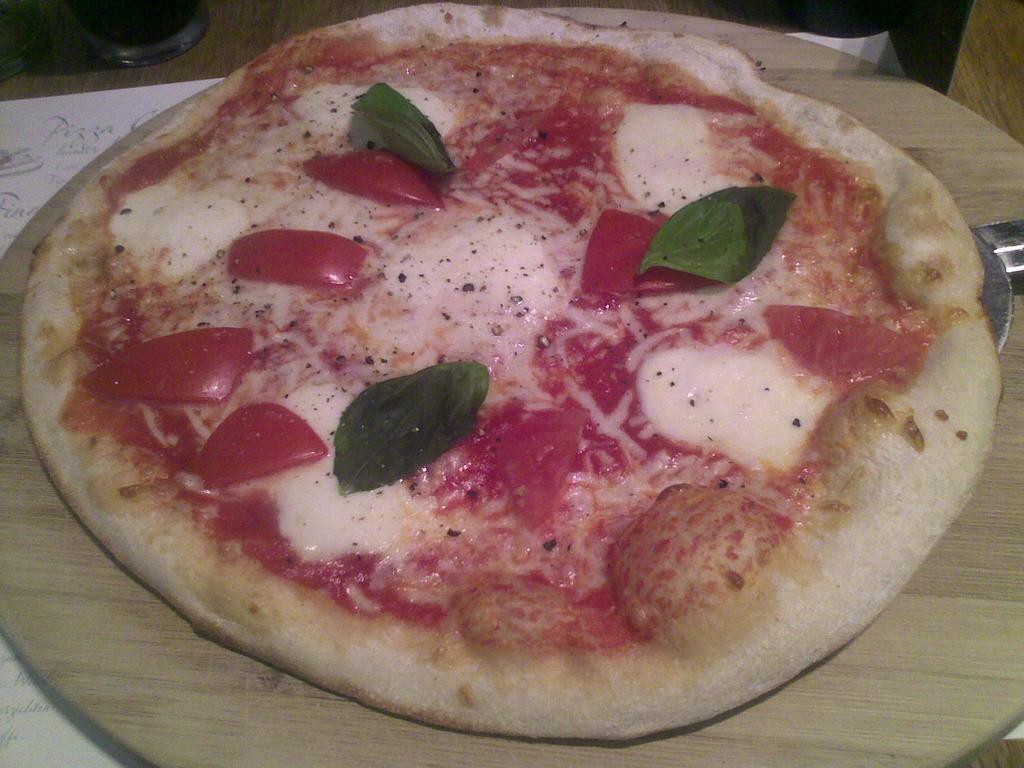What type of food is shown in the image? There is a pizza in the image. How is the pizza being held or contained? The pizza is in a pan. On what surface is the pan placed? The pan is on a wooden surface. What are some of the toppings on the pizza? There is cheese, tomato slices, and leaves on the pizza. What is the beginner's opinion on the pizza in the image? There is no information about a beginner's opinion in the image, as it only shows the pizza and its toppings. 